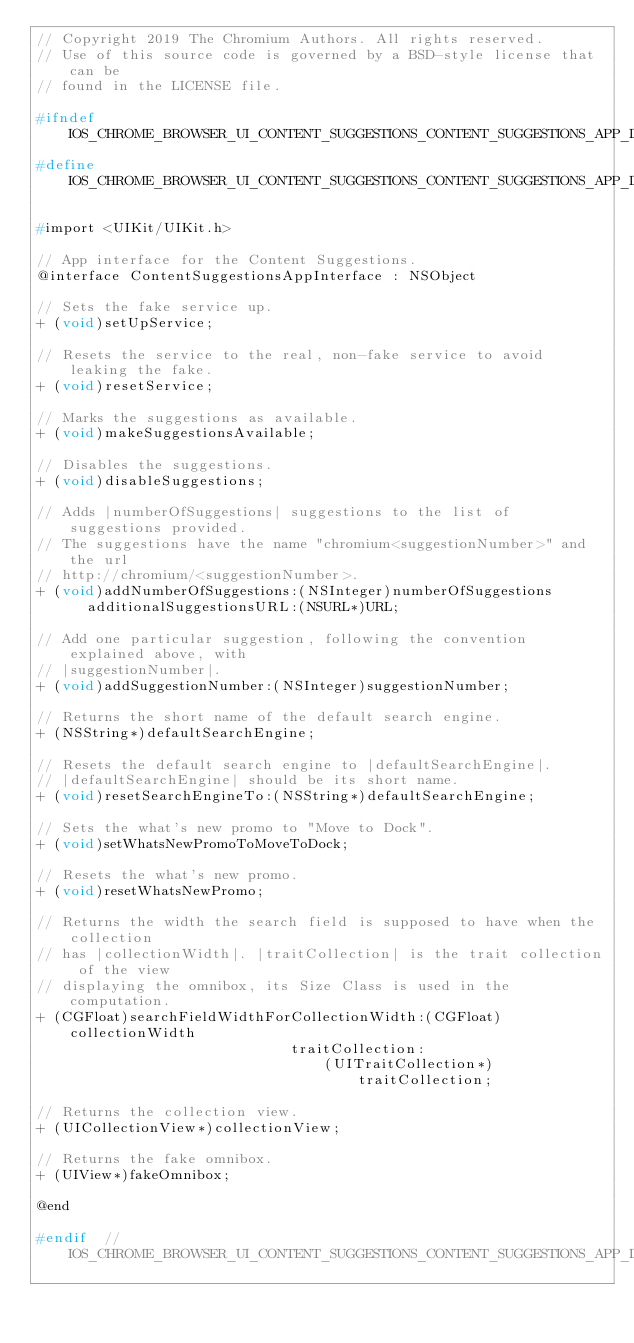Convert code to text. <code><loc_0><loc_0><loc_500><loc_500><_C_>// Copyright 2019 The Chromium Authors. All rights reserved.
// Use of this source code is governed by a BSD-style license that can be
// found in the LICENSE file.

#ifndef IOS_CHROME_BROWSER_UI_CONTENT_SUGGESTIONS_CONTENT_SUGGESTIONS_APP_INTERFACE_H_
#define IOS_CHROME_BROWSER_UI_CONTENT_SUGGESTIONS_CONTENT_SUGGESTIONS_APP_INTERFACE_H_

#import <UIKit/UIKit.h>

// App interface for the Content Suggestions.
@interface ContentSuggestionsAppInterface : NSObject

// Sets the fake service up.
+ (void)setUpService;

// Resets the service to the real, non-fake service to avoid leaking the fake.
+ (void)resetService;

// Marks the suggestions as available.
+ (void)makeSuggestionsAvailable;

// Disables the suggestions.
+ (void)disableSuggestions;

// Adds |numberOfSuggestions| suggestions to the list of suggestions provided.
// The suggestions have the name "chromium<suggestionNumber>" and the url
// http://chromium/<suggestionNumber>.
+ (void)addNumberOfSuggestions:(NSInteger)numberOfSuggestions
      additionalSuggestionsURL:(NSURL*)URL;

// Add one particular suggestion, following the convention explained above, with
// |suggestionNumber|.
+ (void)addSuggestionNumber:(NSInteger)suggestionNumber;

// Returns the short name of the default search engine.
+ (NSString*)defaultSearchEngine;

// Resets the default search engine to |defaultSearchEngine|.
// |defaultSearchEngine| should be its short name.
+ (void)resetSearchEngineTo:(NSString*)defaultSearchEngine;

// Sets the what's new promo to "Move to Dock".
+ (void)setWhatsNewPromoToMoveToDock;

// Resets the what's new promo.
+ (void)resetWhatsNewPromo;

// Returns the width the search field is supposed to have when the collection
// has |collectionWidth|. |traitCollection| is the trait collection of the view
// displaying the omnibox, its Size Class is used in the computation.
+ (CGFloat)searchFieldWidthForCollectionWidth:(CGFloat)collectionWidth
                              traitCollection:
                                  (UITraitCollection*)traitCollection;

// Returns the collection view.
+ (UICollectionView*)collectionView;

// Returns the fake omnibox.
+ (UIView*)fakeOmnibox;

@end

#endif  // IOS_CHROME_BROWSER_UI_CONTENT_SUGGESTIONS_CONTENT_SUGGESTIONS_APP_INTERFACE_H_
</code> 